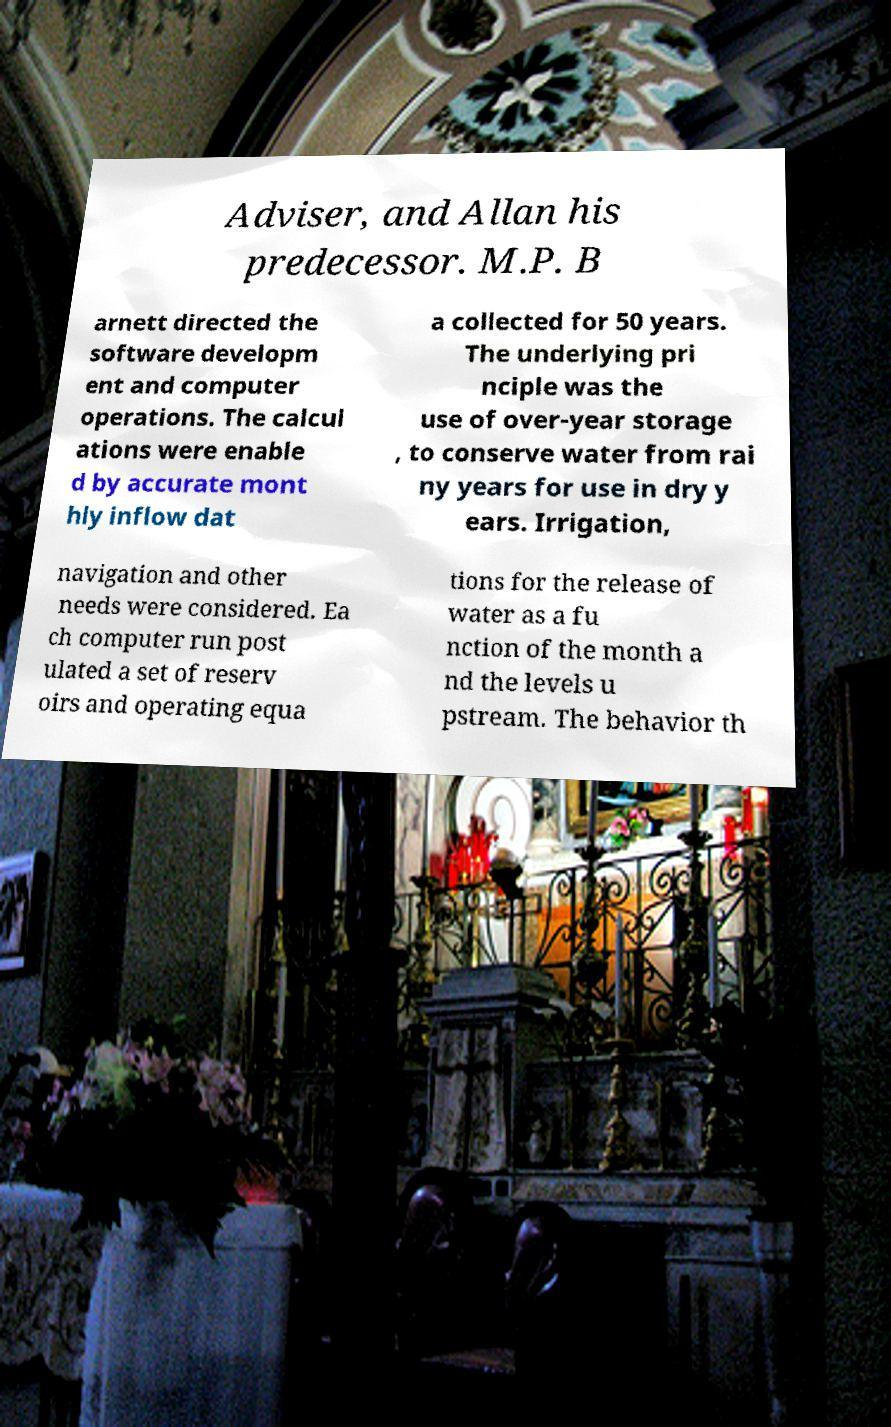Can you accurately transcribe the text from the provided image for me? Adviser, and Allan his predecessor. M.P. B arnett directed the software developm ent and computer operations. The calcul ations were enable d by accurate mont hly inflow dat a collected for 50 years. The underlying pri nciple was the use of over-year storage , to conserve water from rai ny years for use in dry y ears. Irrigation, navigation and other needs were considered. Ea ch computer run post ulated a set of reserv oirs and operating equa tions for the release of water as a fu nction of the month a nd the levels u pstream. The behavior th 